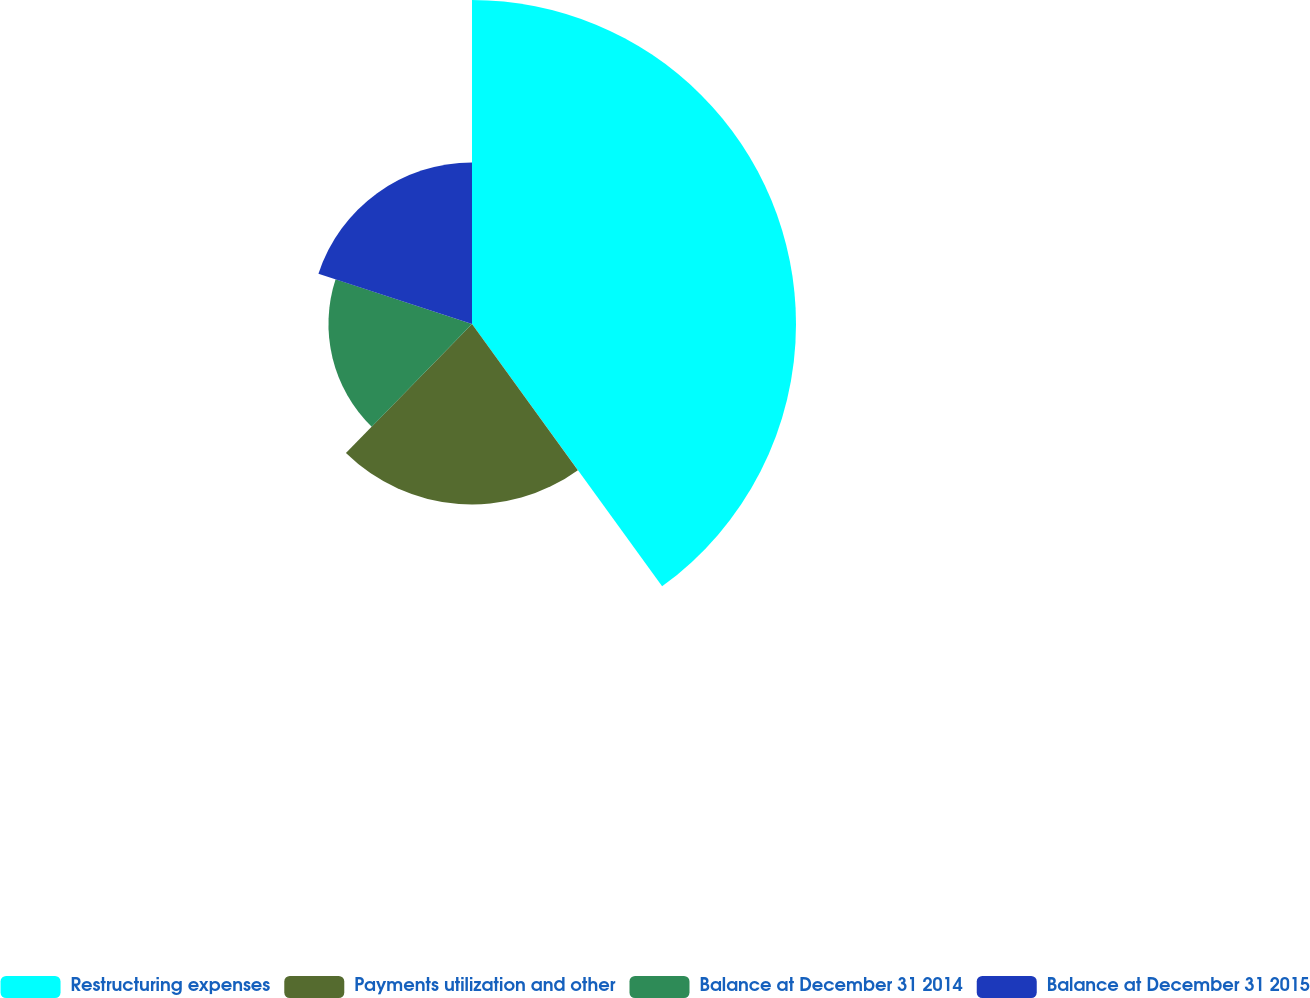Convert chart. <chart><loc_0><loc_0><loc_500><loc_500><pie_chart><fcel>Restructuring expenses<fcel>Payments utilization and other<fcel>Balance at December 31 2014<fcel>Balance at December 31 2015<nl><fcel>40.02%<fcel>22.29%<fcel>17.73%<fcel>19.96%<nl></chart> 